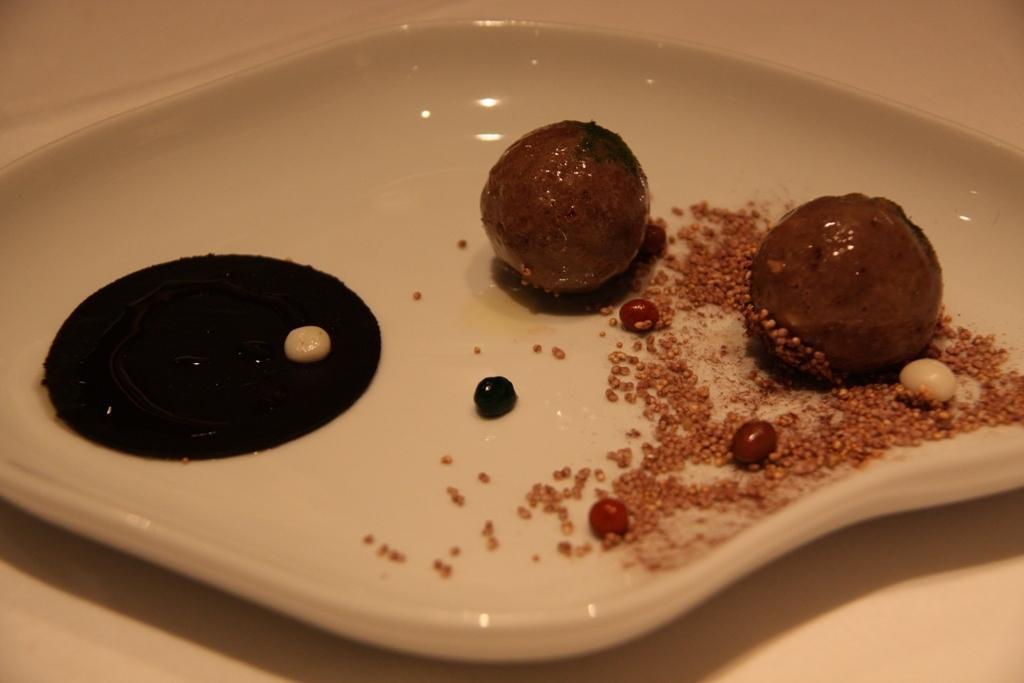How would you summarize this image in a sentence or two? In the picture we can see a white color plate on it, we can see a two pieces of sweet and some grains with garnish on the plate and some black color cream. 